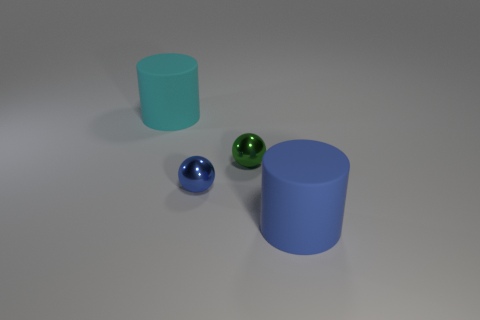Add 2 large rubber cylinders. How many objects exist? 6 Add 2 large cylinders. How many large cylinders exist? 4 Subtract 0 green cubes. How many objects are left? 4 Subtract all blue things. Subtract all yellow blocks. How many objects are left? 2 Add 1 large cyan cylinders. How many large cyan cylinders are left? 2 